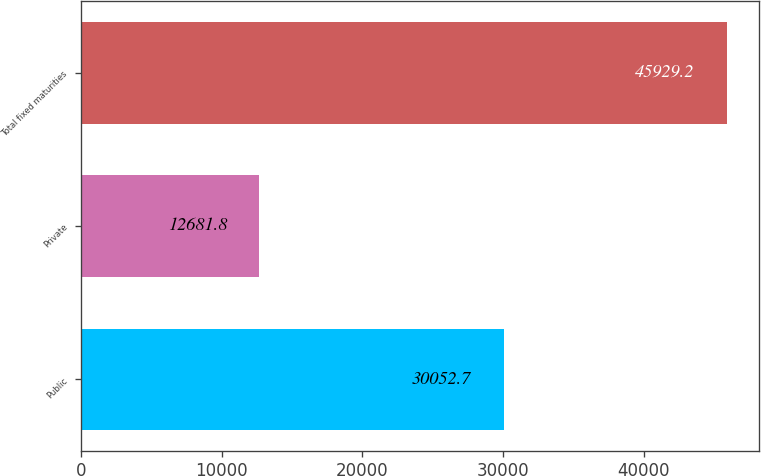Convert chart. <chart><loc_0><loc_0><loc_500><loc_500><bar_chart><fcel>Public<fcel>Private<fcel>Total fixed maturities<nl><fcel>30052.7<fcel>12681.8<fcel>45929.2<nl></chart> 